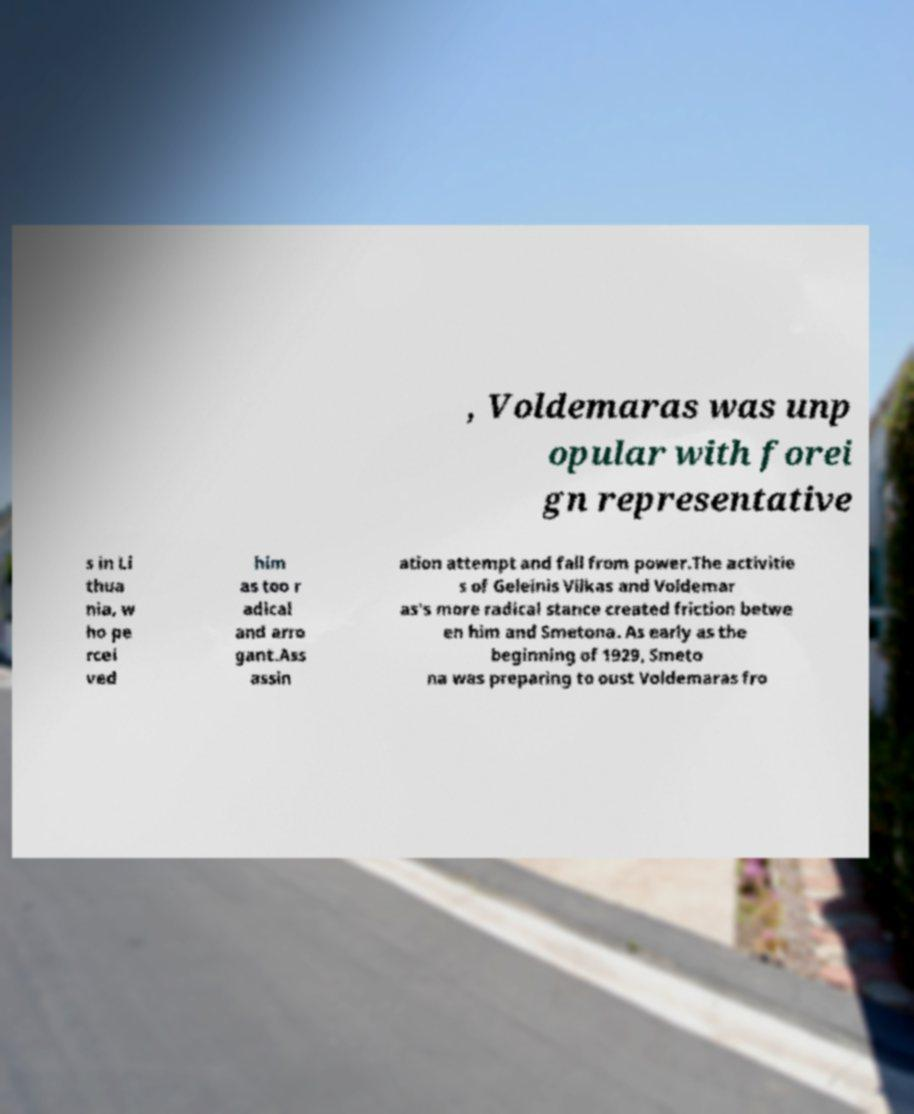There's text embedded in this image that I need extracted. Can you transcribe it verbatim? , Voldemaras was unp opular with forei gn representative s in Li thua nia, w ho pe rcei ved him as too r adical and arro gant.Ass assin ation attempt and fall from power.The activitie s of Geleinis Vilkas and Voldemar as's more radical stance created friction betwe en him and Smetona. As early as the beginning of 1929, Smeto na was preparing to oust Voldemaras fro 